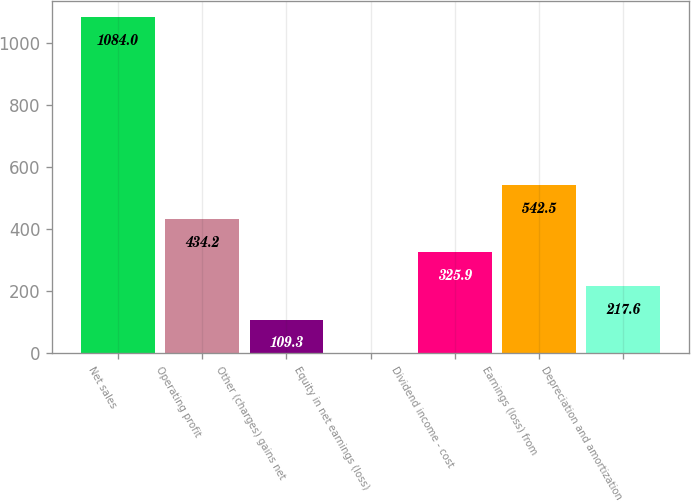Convert chart to OTSL. <chart><loc_0><loc_0><loc_500><loc_500><bar_chart><fcel>Net sales<fcel>Operating profit<fcel>Other (charges) gains net<fcel>Equity in net earnings (loss)<fcel>Dividend income - cost<fcel>Earnings (loss) from<fcel>Depreciation and amortization<nl><fcel>1084<fcel>434.2<fcel>109.3<fcel>1<fcel>325.9<fcel>542.5<fcel>217.6<nl></chart> 